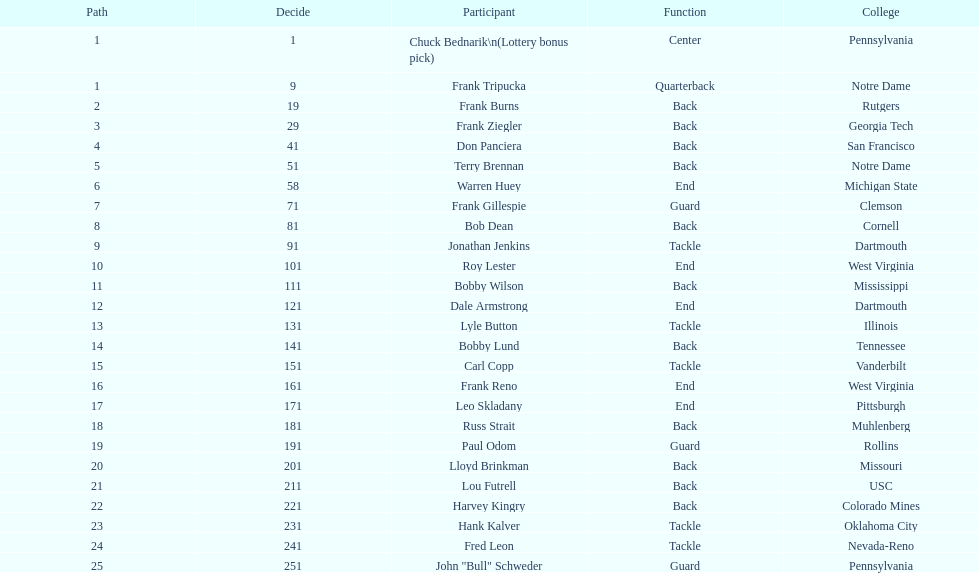Who was picked after roy lester? Bobby Wilson. 